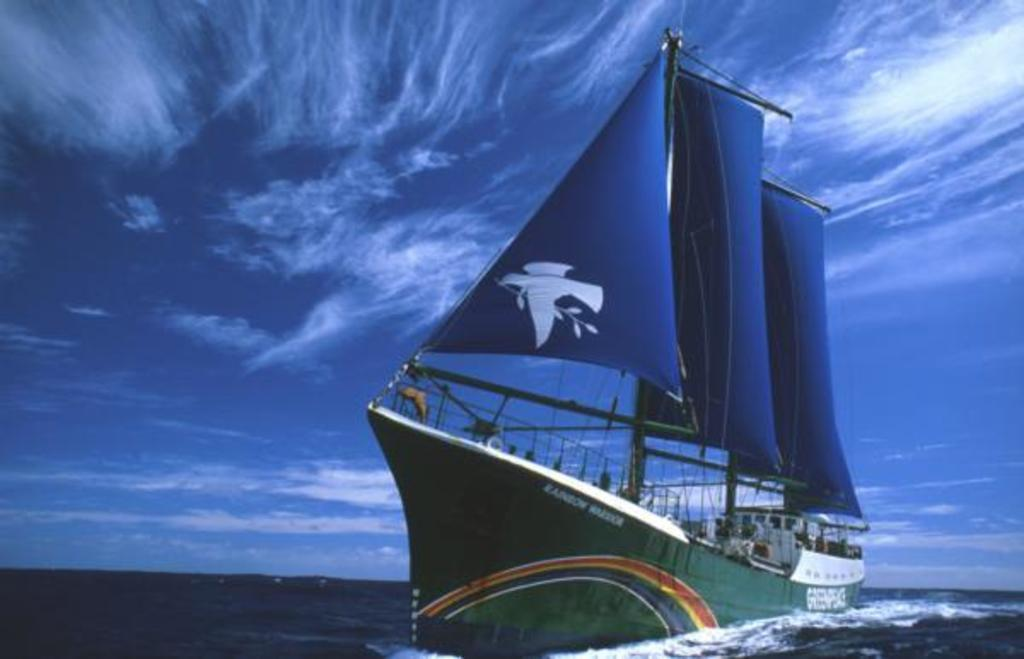What is the main subject of the image? There is a ship in the image. Where is the ship located? The ship is on the water. What is the color of the sky in the image? The sky is blue in the image. How many children are playing on the side of the ship in the image? There are no children present in the image, and the ship does not have a side visible in the image. 